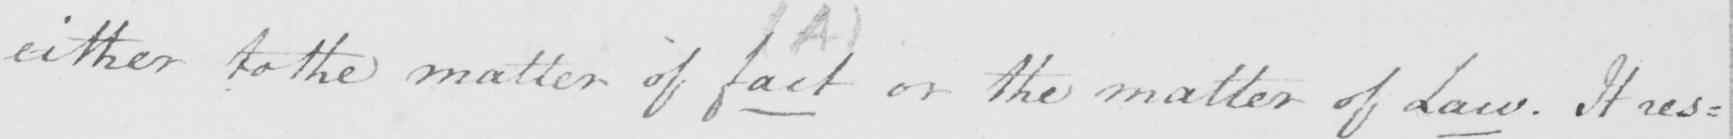Transcribe the text shown in this historical manuscript line. either to the matter of fact or the matter of Law . It res= 